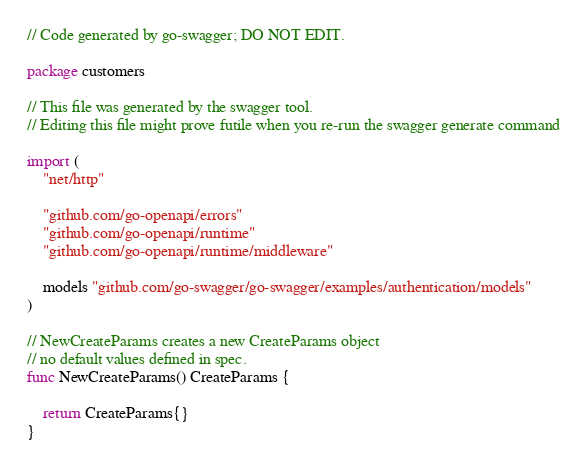Convert code to text. <code><loc_0><loc_0><loc_500><loc_500><_Go_>// Code generated by go-swagger; DO NOT EDIT.

package customers

// This file was generated by the swagger tool.
// Editing this file might prove futile when you re-run the swagger generate command

import (
	"net/http"

	"github.com/go-openapi/errors"
	"github.com/go-openapi/runtime"
	"github.com/go-openapi/runtime/middleware"

	models "github.com/go-swagger/go-swagger/examples/authentication/models"
)

// NewCreateParams creates a new CreateParams object
// no default values defined in spec.
func NewCreateParams() CreateParams {

	return CreateParams{}
}
</code> 